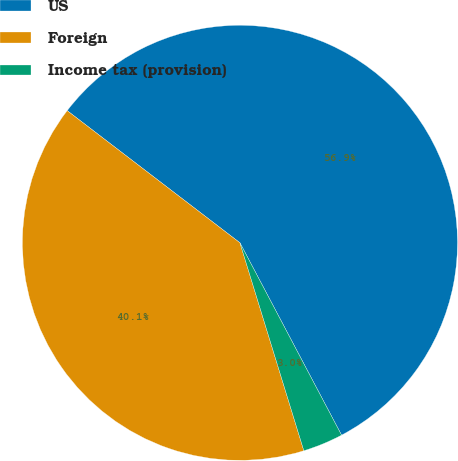Convert chart. <chart><loc_0><loc_0><loc_500><loc_500><pie_chart><fcel>US<fcel>Foreign<fcel>Income tax (provision)<nl><fcel>56.87%<fcel>40.14%<fcel>2.99%<nl></chart> 